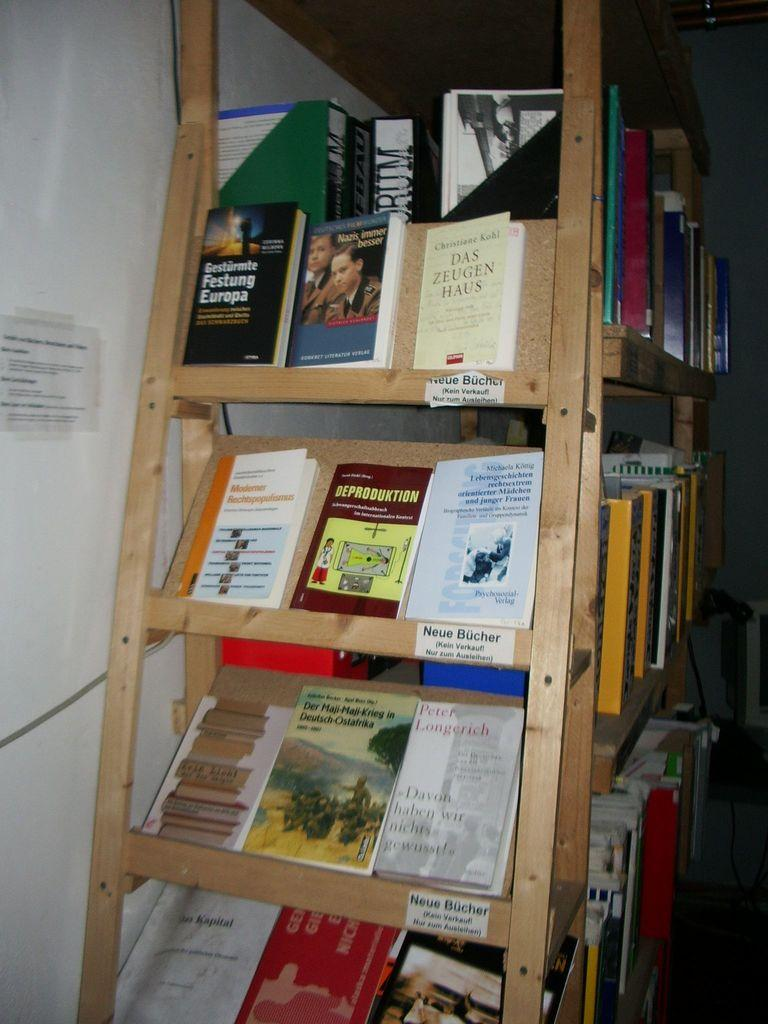<image>
Relay a brief, clear account of the picture shown. A group of German books at the end cap of a book shelf with a sign that reads Neue Bucher. 